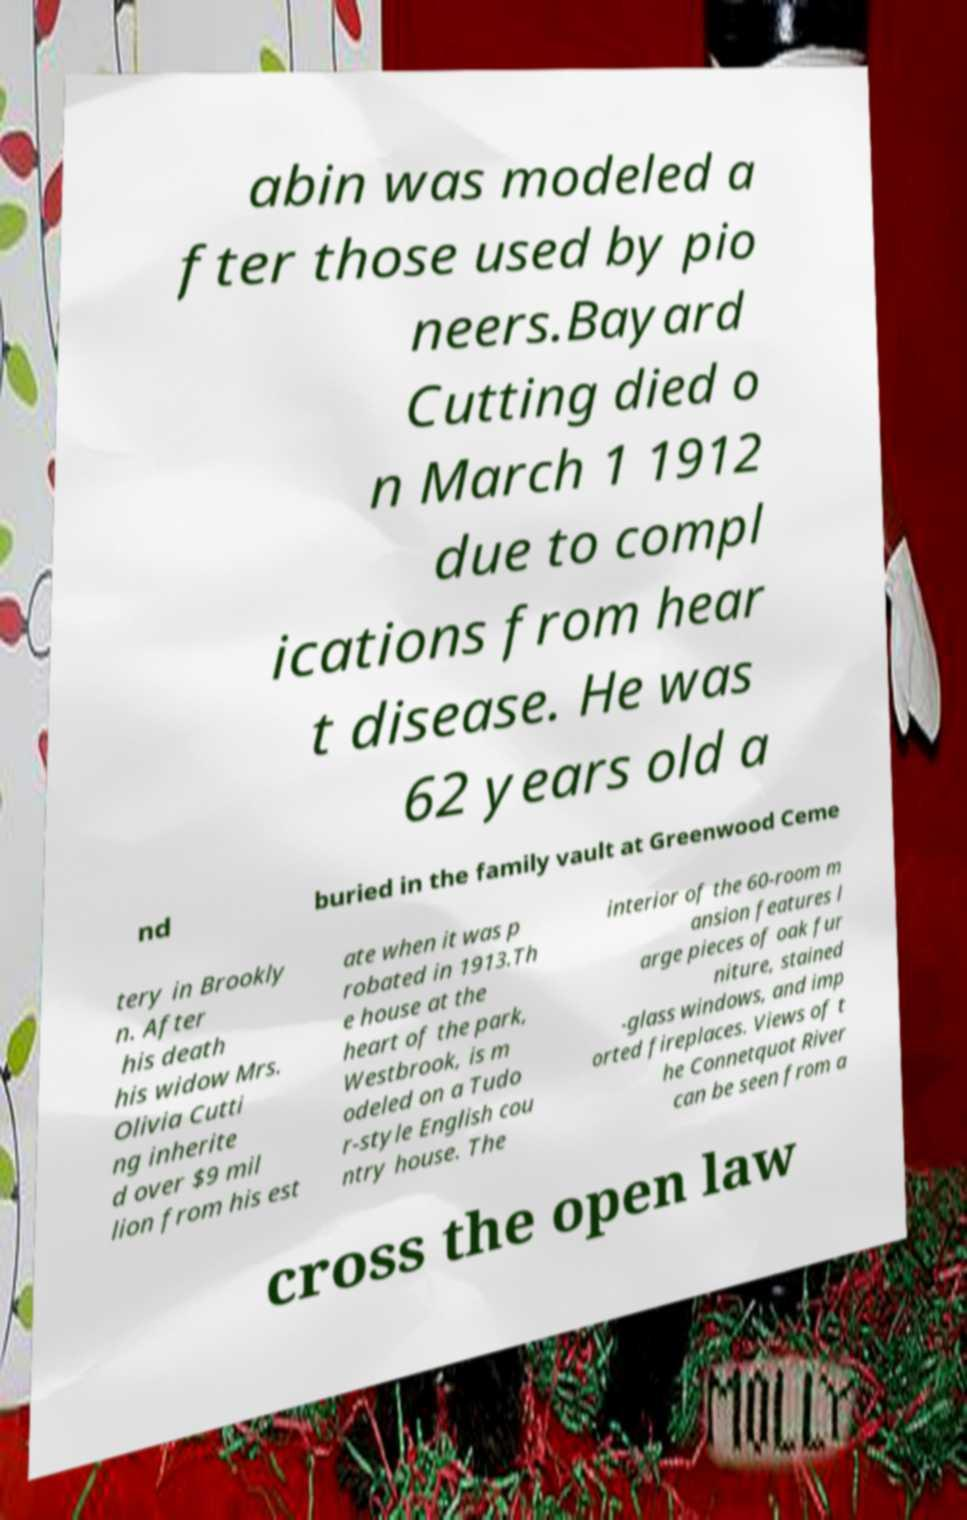For documentation purposes, I need the text within this image transcribed. Could you provide that? abin was modeled a fter those used by pio neers.Bayard Cutting died o n March 1 1912 due to compl ications from hear t disease. He was 62 years old a nd buried in the family vault at Greenwood Ceme tery in Brookly n. After his death his widow Mrs. Olivia Cutti ng inherite d over $9 mil lion from his est ate when it was p robated in 1913.Th e house at the heart of the park, Westbrook, is m odeled on a Tudo r-style English cou ntry house. The interior of the 60-room m ansion features l arge pieces of oak fur niture, stained -glass windows, and imp orted fireplaces. Views of t he Connetquot River can be seen from a cross the open law 